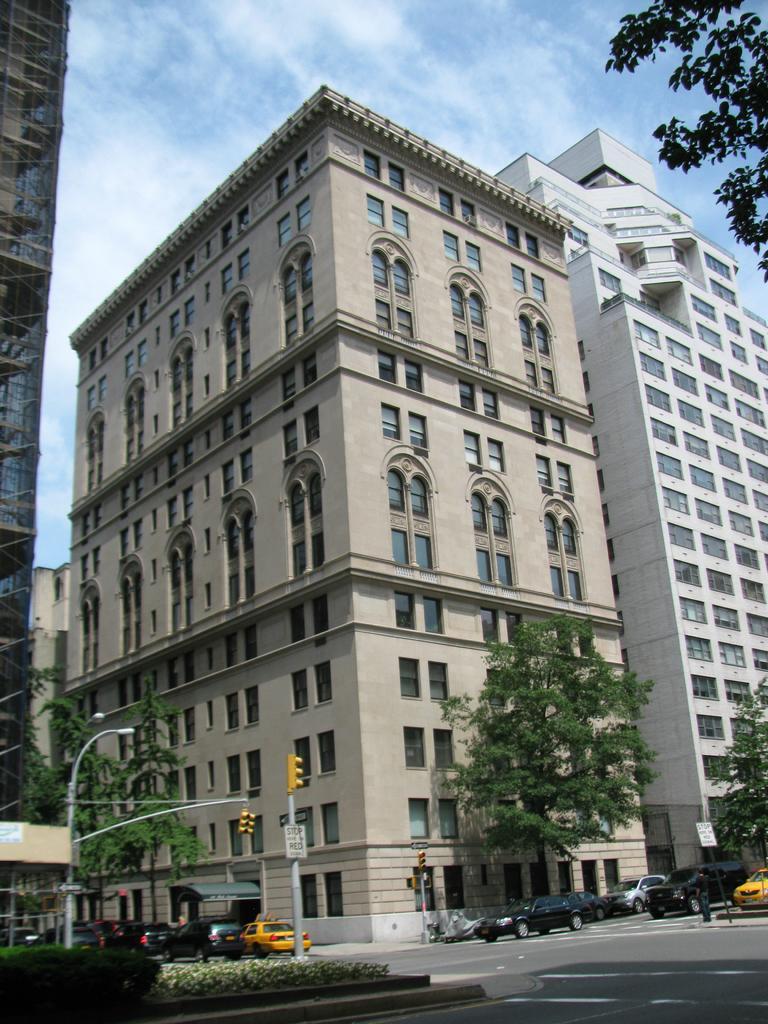Could you give a brief overview of what you see in this image? In this image we can see vehicles moving on the road, we can see shrubs, traffic signal poles, light poles, trees, tower buildings and the sky with clouds in the background. 